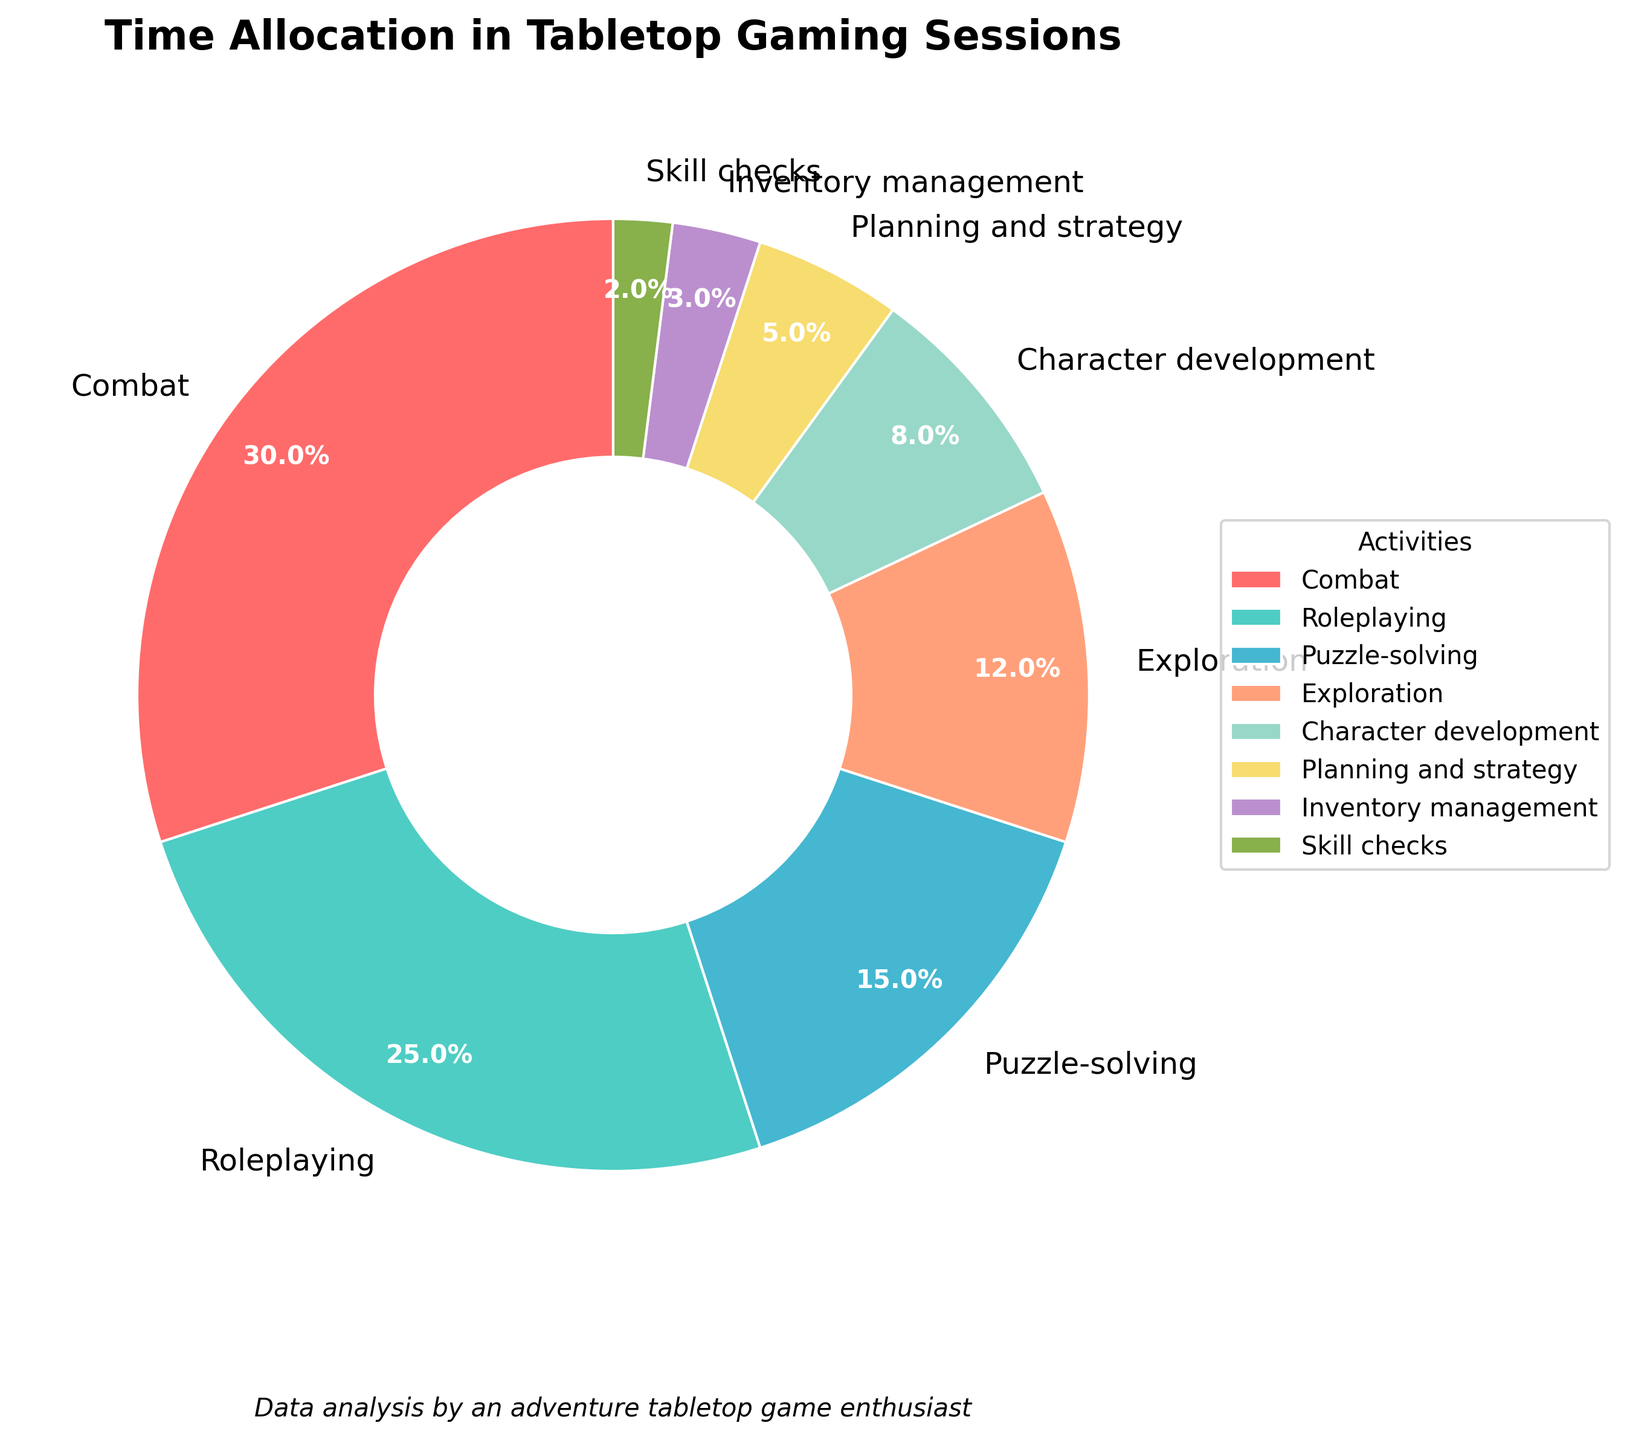Which activity takes up the largest portion of time in tabletop gaming sessions? The activity with the largest percentage segment in the pie chart is the one that occupies the most time. By examining the pie chart, Combat is the largest segment with 30%.
Answer: Combat How much more time is allocated to Combat than to Roleplaying? First, find the percentages for Combat and Roleplaying from the pie chart (30% and 25%, respectively). Then, subtract the smaller percentage from the larger percentage: 30% - 25% = 5%.
Answer: 5% What percentage of time is spent on non-combat activities? To find the percentage of time spent on non-combat activities, sum the percentages of all other activities and subtract the Combat percentage from 100%. The non-combat activities are Roleplaying (25%), Puzzle-solving (15%), Exploration (12%), Character development (8%), Planning and strategy (5%), Inventory management (3%), and Skill checks (2%). Their sum is 70%.
Answer: 70% Which two activities together make up the smallest combined percentage of time? Identify the two activities with the smallest percentages: Inventory management (3%) and Skill checks (2%). Add their percentages: 3% + 2% = 5%.
Answer: Inventory management and Skill checks How does the time allocation for Roleplaying compare to Combat and Puzzle-solving combined? First, find the combined percentage for Combat and Puzzle-solving: 30% (Combat) + 15% (Puzzle-solving) = 45%. Compare it to Roleplaying which is 25%. Roleplaying is smaller.
Answer: Roleplaying is less What is the percentage difference between Exploration and Character development? Find the percentages for Exploration (12%) and Character development (8%), then subtract the smaller percentage from the larger: 12% - 8% = 4%.
Answer: 4% If you combine the time spent on Exploration and Planning and strategy, what percentage of time is left for other activities? First, find the combined percentage for Exploration and Planning and strategy: 12% + 5% = 17%. Subtract this sum from 100% to find the remaining percentage: 100% - 17% = 83%.
Answer: 83% Which visual attributes are used to distinguish between different activities in the pie chart? Different activities are distinguished by varying colors and labels. Each segment has a unique color and a label indicating the activity name and percentage.
Answer: Colors and labels How does the time allocated to Skill checks compare to Inventory management? Compare the percentages of Skill checks (2%) and Inventory management (3%). Inventory management takes more time.
Answer: Inventory management takes more time What is the total percentage of time spent on Puzzle-solving, Exploration, and Character development combined? Add the percentages for Puzzle-solving (15%), Exploration (12%), and Character development (8%): 15% + 12% + 8% = 35%.
Answer: 35% 